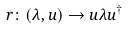<formula> <loc_0><loc_0><loc_500><loc_500>r \colon ( \lambda , u ) \to u \lambda u ^ { \dagger }</formula> 